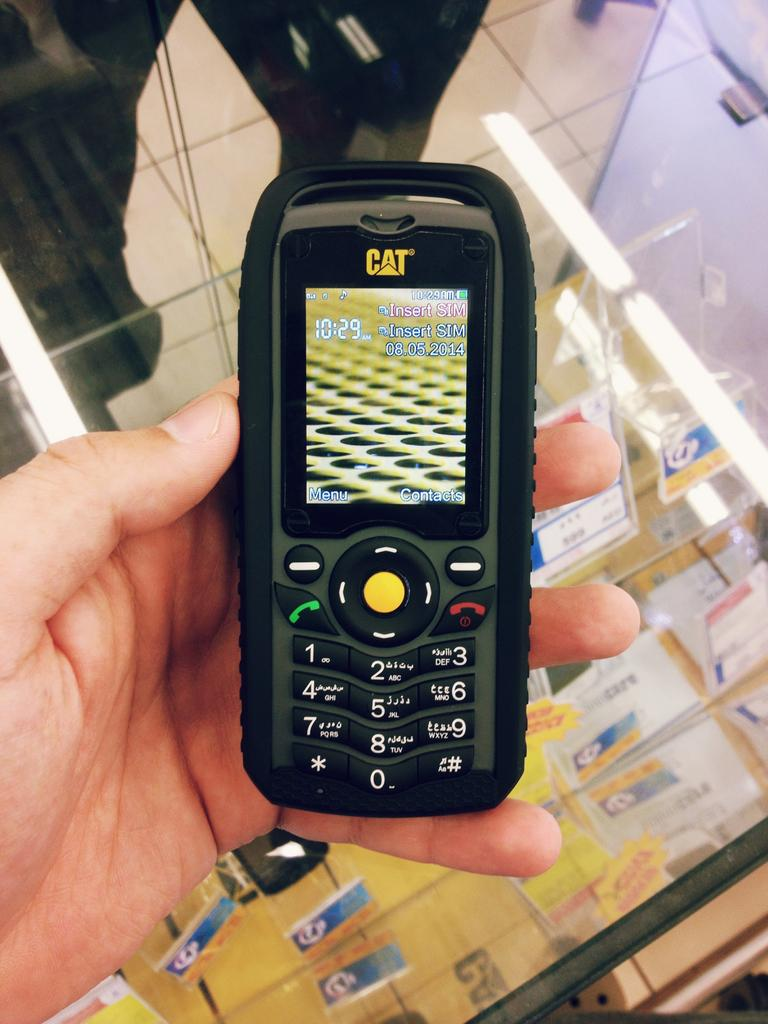Provide a one-sentence caption for the provided image. Cellphone that reads 10:29 and needs a SIM card inserted. 